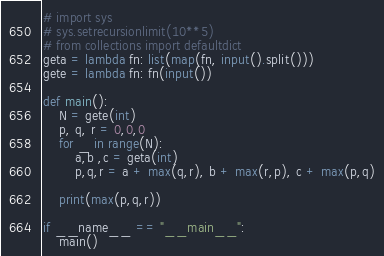Convert code to text. <code><loc_0><loc_0><loc_500><loc_500><_Python_># import sys
# sys.setrecursionlimit(10**5)
# from collections import defaultdict
geta = lambda fn: list(map(fn, input().split()))
gete = lambda fn: fn(input())

def main():
    N = gete(int)
    p, q, r = 0,0,0
    for _ in range(N):
        a,b ,c = geta(int)
        p,q,r = a + max(q,r), b + max(r,p), c + max(p,q)

    print(max(p,q,r))

if __name__ == "__main__":
    main()</code> 